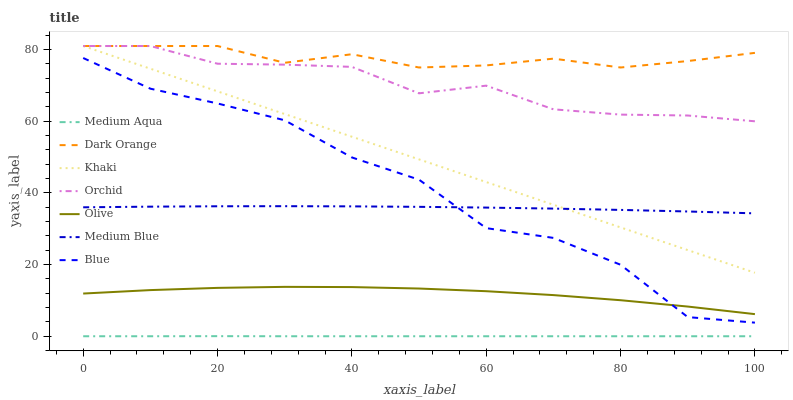Does Medium Aqua have the minimum area under the curve?
Answer yes or no. Yes. Does Dark Orange have the maximum area under the curve?
Answer yes or no. Yes. Does Khaki have the minimum area under the curve?
Answer yes or no. No. Does Khaki have the maximum area under the curve?
Answer yes or no. No. Is Khaki the smoothest?
Answer yes or no. Yes. Is Blue the roughest?
Answer yes or no. Yes. Is Dark Orange the smoothest?
Answer yes or no. No. Is Dark Orange the roughest?
Answer yes or no. No. Does Medium Aqua have the lowest value?
Answer yes or no. Yes. Does Khaki have the lowest value?
Answer yes or no. No. Does Orchid have the highest value?
Answer yes or no. Yes. Does Medium Blue have the highest value?
Answer yes or no. No. Is Medium Aqua less than Blue?
Answer yes or no. Yes. Is Khaki greater than Blue?
Answer yes or no. Yes. Does Olive intersect Blue?
Answer yes or no. Yes. Is Olive less than Blue?
Answer yes or no. No. Is Olive greater than Blue?
Answer yes or no. No. Does Medium Aqua intersect Blue?
Answer yes or no. No. 